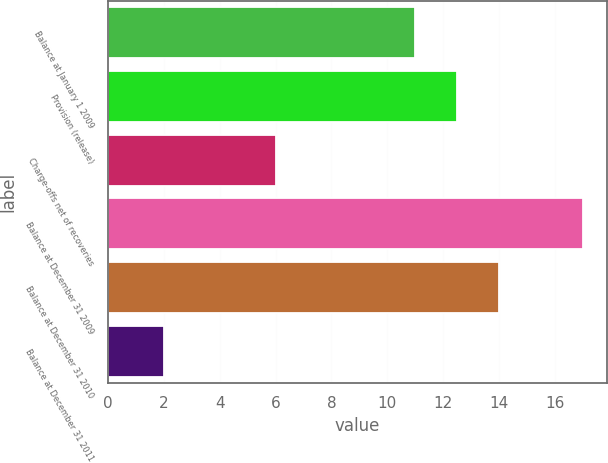Convert chart to OTSL. <chart><loc_0><loc_0><loc_500><loc_500><bar_chart><fcel>Balance at January 1 2009<fcel>Provision (release)<fcel>Charge-offs net of recoveries<fcel>Balance at December 31 2009<fcel>Balance at December 31 2010<fcel>Balance at December 31 2011<nl><fcel>11<fcel>12.5<fcel>6<fcel>17<fcel>14<fcel>2<nl></chart> 